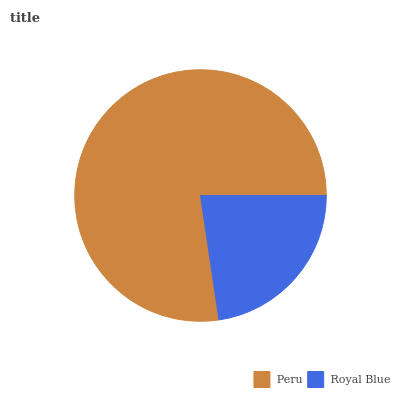Is Royal Blue the minimum?
Answer yes or no. Yes. Is Peru the maximum?
Answer yes or no. Yes. Is Royal Blue the maximum?
Answer yes or no. No. Is Peru greater than Royal Blue?
Answer yes or no. Yes. Is Royal Blue less than Peru?
Answer yes or no. Yes. Is Royal Blue greater than Peru?
Answer yes or no. No. Is Peru less than Royal Blue?
Answer yes or no. No. Is Peru the high median?
Answer yes or no. Yes. Is Royal Blue the low median?
Answer yes or no. Yes. Is Royal Blue the high median?
Answer yes or no. No. Is Peru the low median?
Answer yes or no. No. 